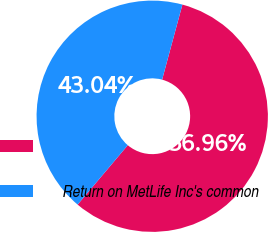<chart> <loc_0><loc_0><loc_500><loc_500><pie_chart><ecel><fcel>Return on MetLife Inc's common<nl><fcel>56.96%<fcel>43.04%<nl></chart> 